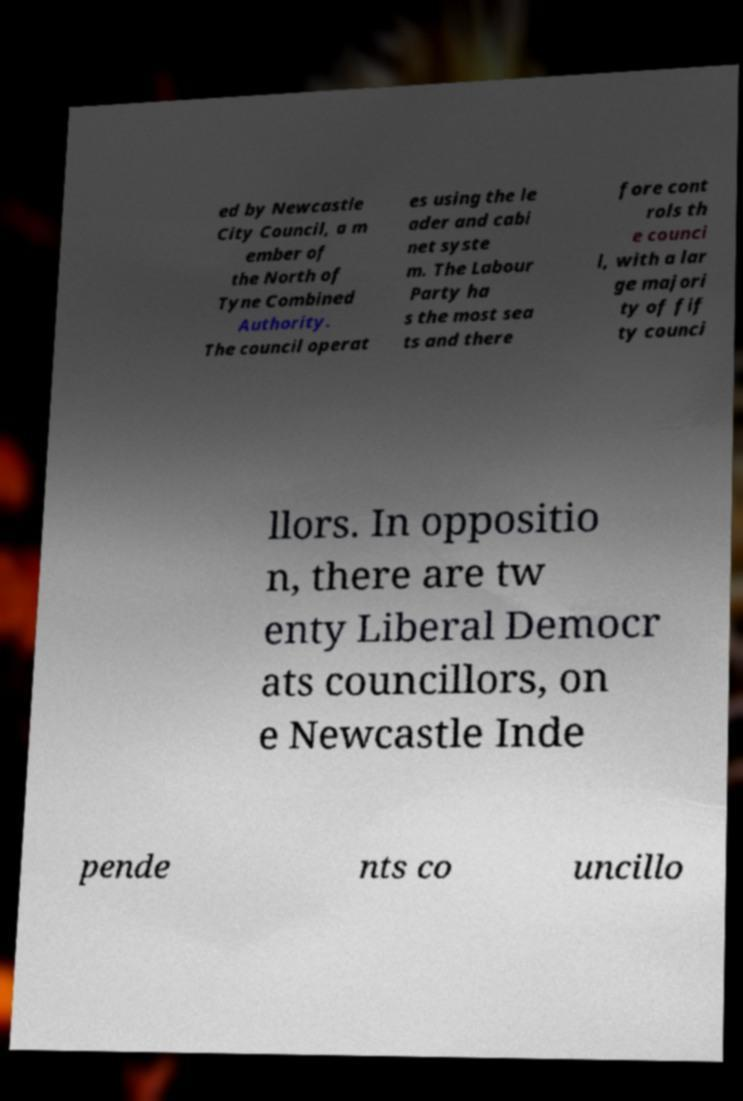Can you accurately transcribe the text from the provided image for me? ed by Newcastle City Council, a m ember of the North of Tyne Combined Authority. The council operat es using the le ader and cabi net syste m. The Labour Party ha s the most sea ts and there fore cont rols th e counci l, with a lar ge majori ty of fif ty counci llors. In oppositio n, there are tw enty Liberal Democr ats councillors, on e Newcastle Inde pende nts co uncillo 